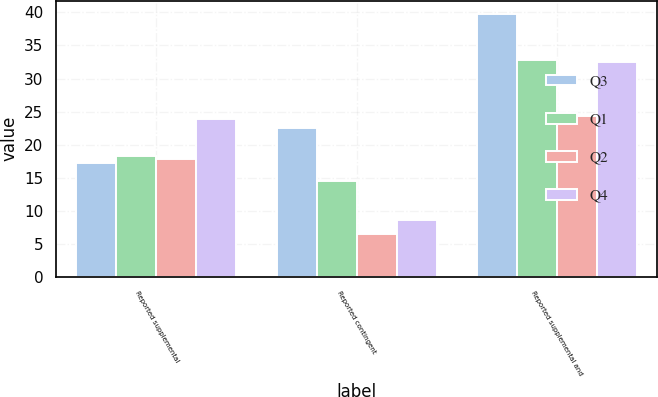Convert chart. <chart><loc_0><loc_0><loc_500><loc_500><stacked_bar_chart><ecel><fcel>Reported supplemental<fcel>Reported contingent<fcel>Reported supplemental and<nl><fcel>Q3<fcel>17.3<fcel>22.5<fcel>39.8<nl><fcel>Q1<fcel>18.3<fcel>14.5<fcel>32.8<nl><fcel>Q2<fcel>17.8<fcel>6.5<fcel>24.3<nl><fcel>Q4<fcel>23.9<fcel>8.6<fcel>32.5<nl></chart> 